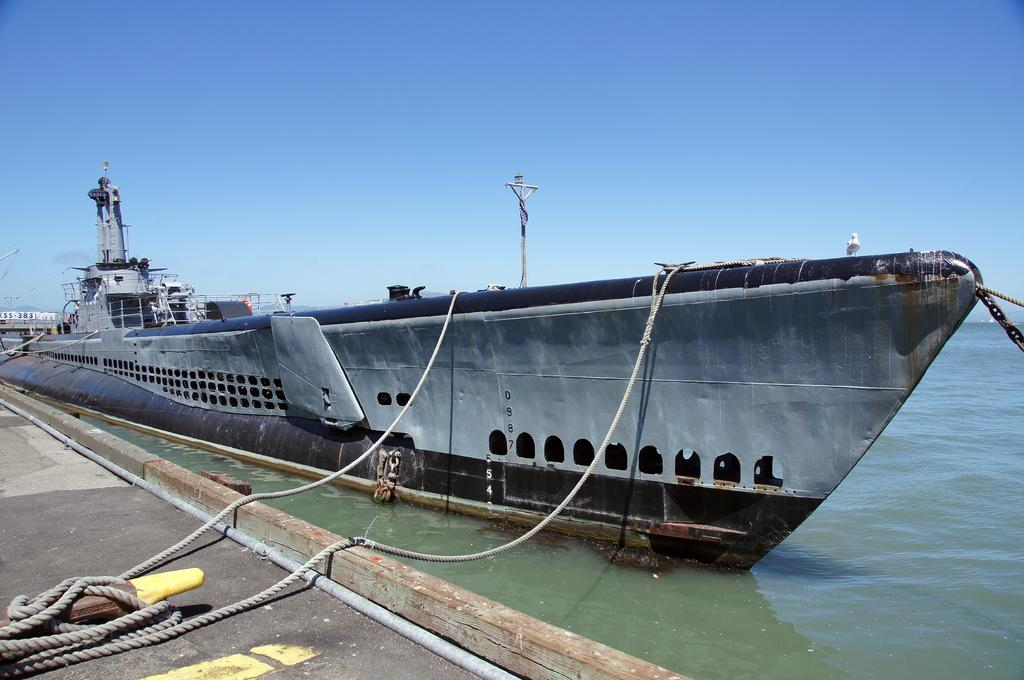What is the main subject of the image? The main subject of the image is a big ship. Where is the ship located in the image? The ship is on the water in the image. What else can be seen in the image besides the ship? There is a road in the image. Are there any additional objects or features on the road? Yes, ropes are present on the road. Can you see a tramp performing tricks on the ship in the image? No, there is no tramp performing tricks on the ship in the image. 